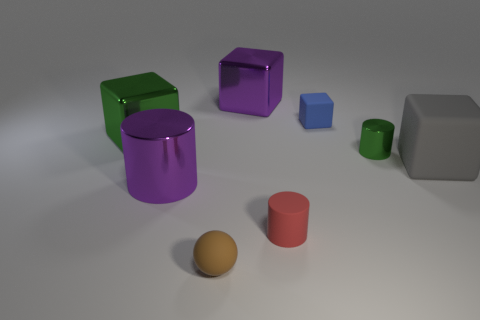What color is the sphere?
Ensure brevity in your answer.  Brown. What is the material of the thing that is behind the brown rubber object and in front of the big shiny cylinder?
Ensure brevity in your answer.  Rubber. There is a metal block that is in front of the tiny rubber thing that is behind the tiny green metallic object; are there any big green metal blocks that are behind it?
Keep it short and to the point. No. What size is the cube that is the same color as the large cylinder?
Make the answer very short. Large. There is a purple metal cylinder; are there any gray rubber things in front of it?
Ensure brevity in your answer.  No. What number of other things are there of the same shape as the red object?
Your answer should be compact. 2. There is a shiny cylinder that is the same size as the gray matte block; what is its color?
Your answer should be compact. Purple. Is the number of cylinders right of the blue thing less than the number of metallic cylinders that are in front of the red cylinder?
Give a very brief answer. No. There is a matte thing to the right of the small rubber thing behind the large matte cube; what number of purple blocks are behind it?
Your answer should be compact. 1. There is a purple thing that is the same shape as the big gray object; what size is it?
Provide a succinct answer. Large. 